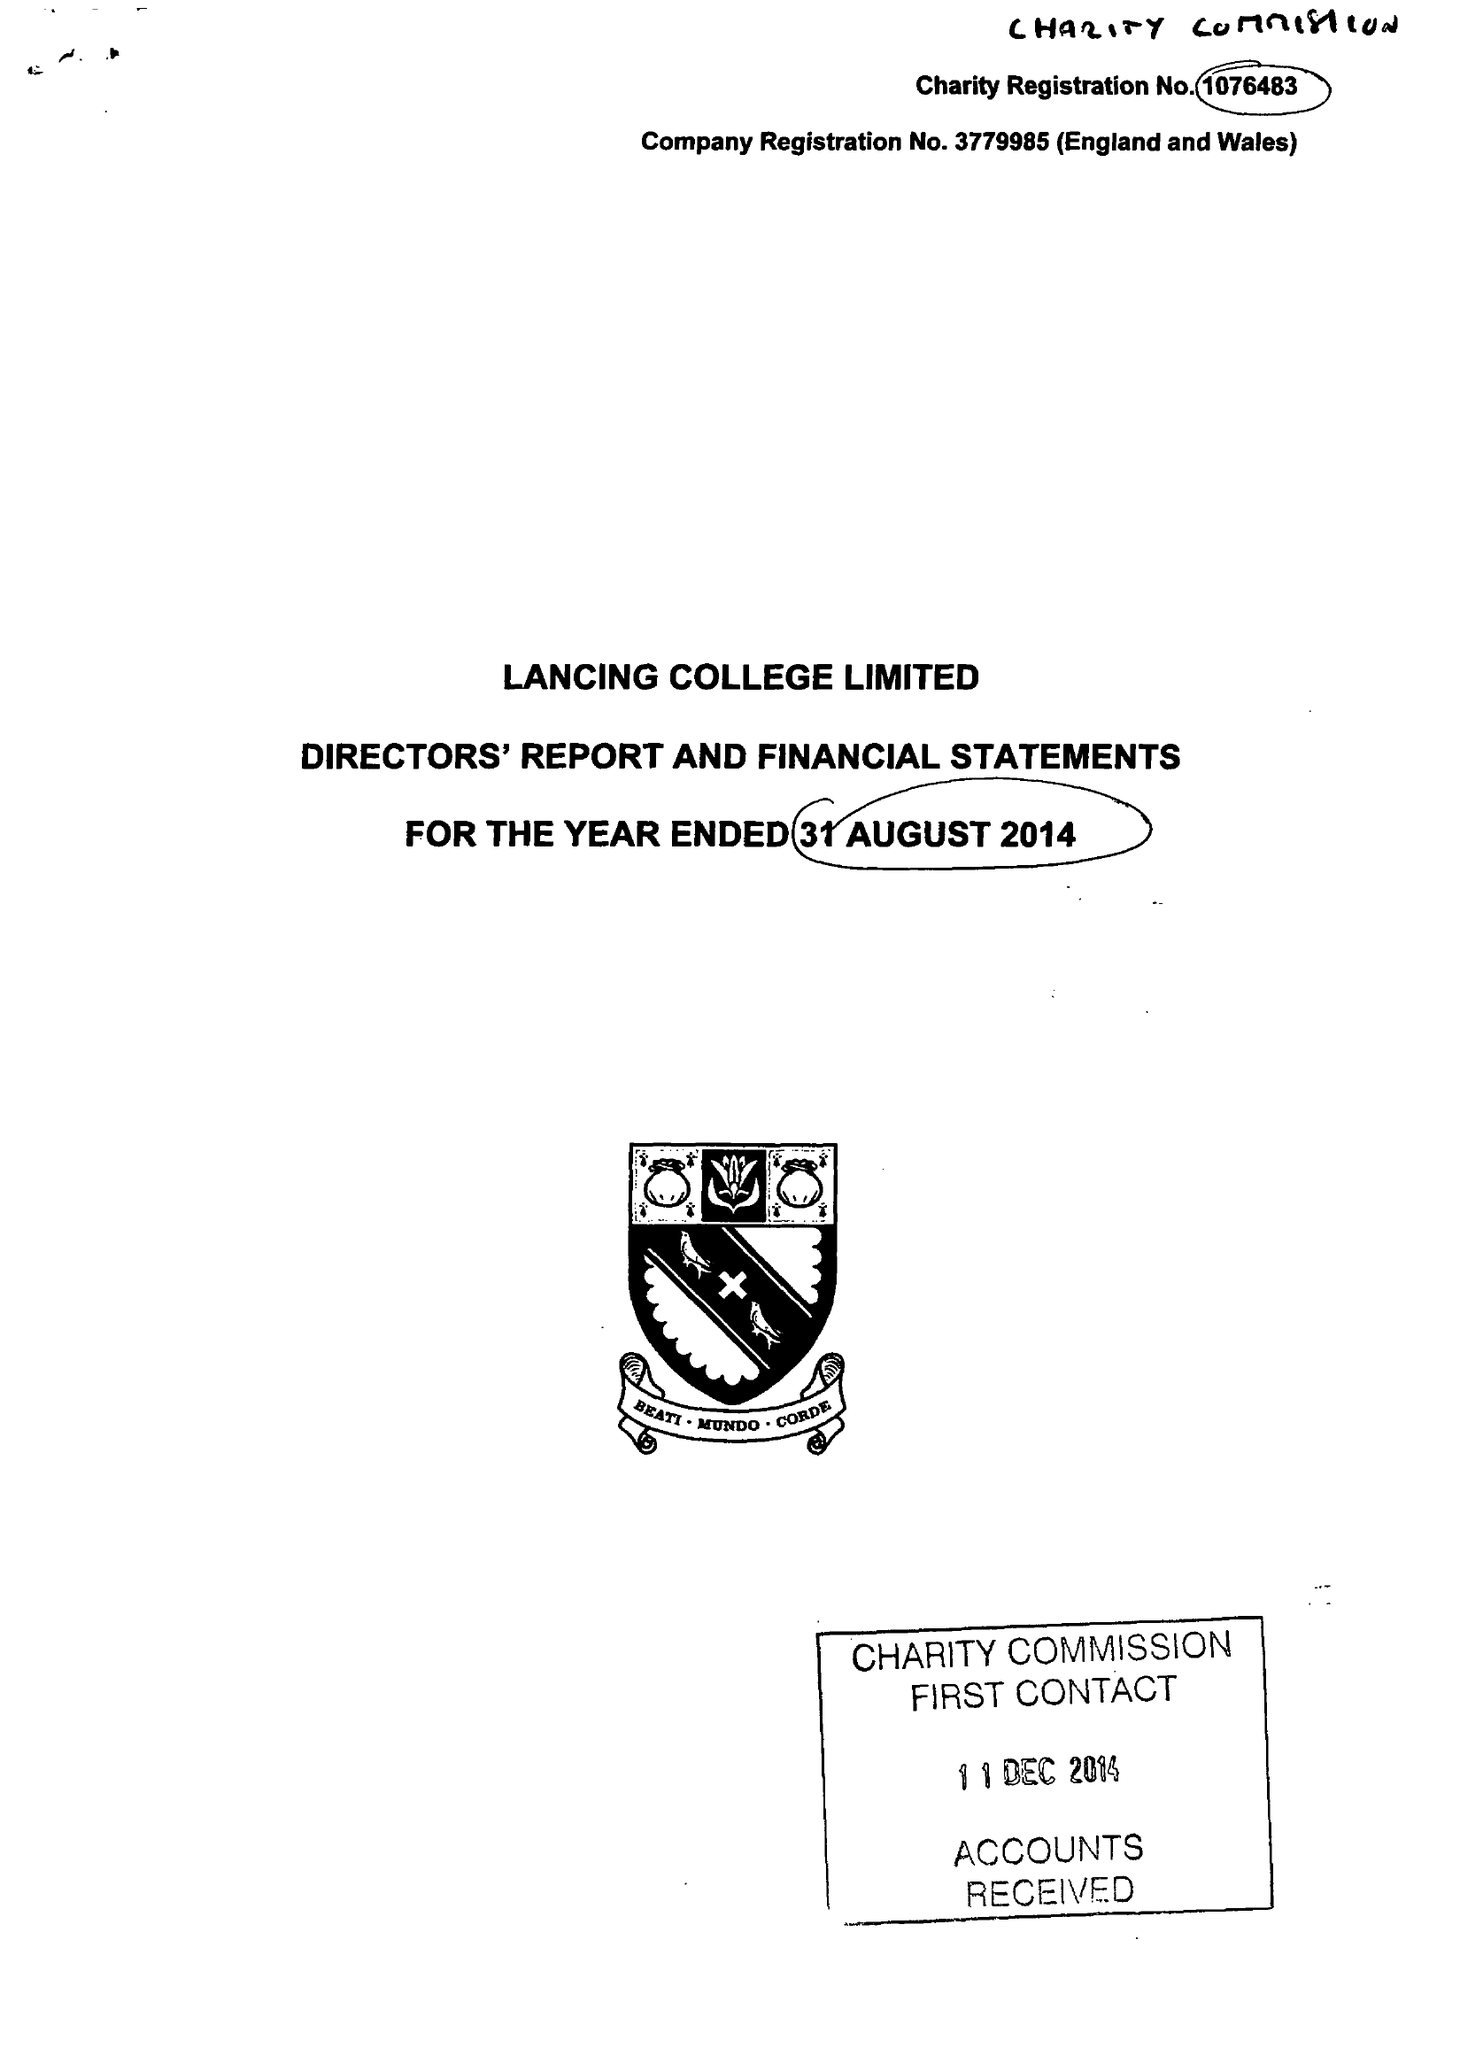What is the value for the address__post_town?
Answer the question using a single word or phrase. LANCING 